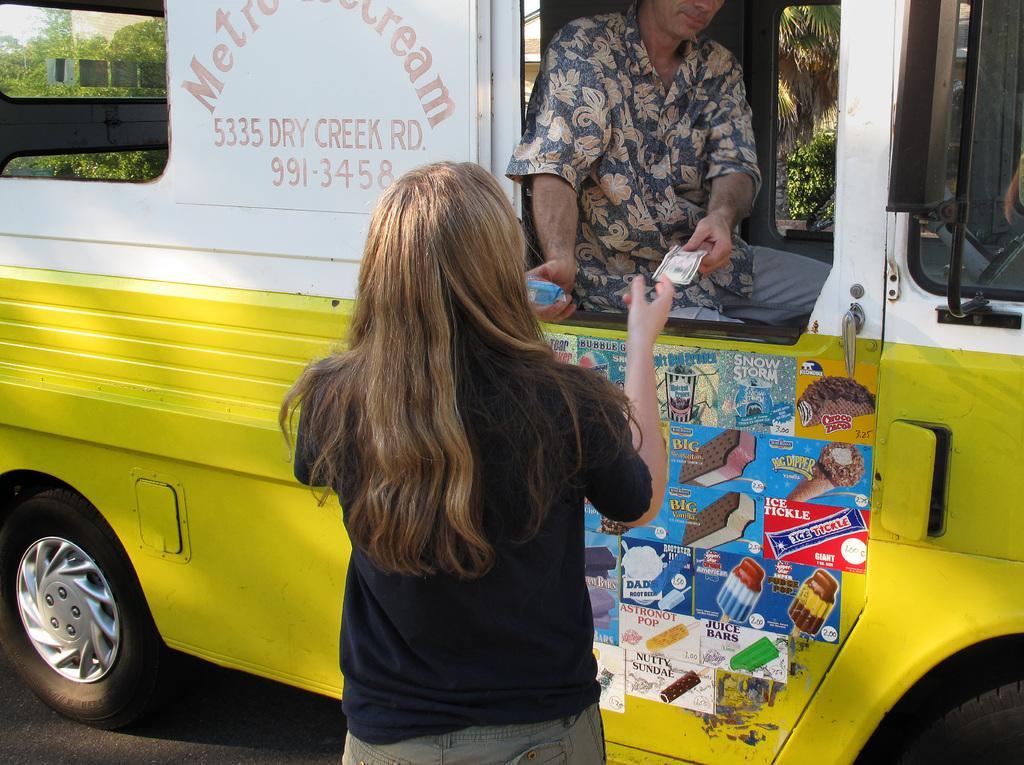How would you summarize this image in a sentence or two? In the picture there is a vehicle and a woman is collecting ice cream and cash from a person sitting in the vehicle,the vehicle is in yellow and white color. 